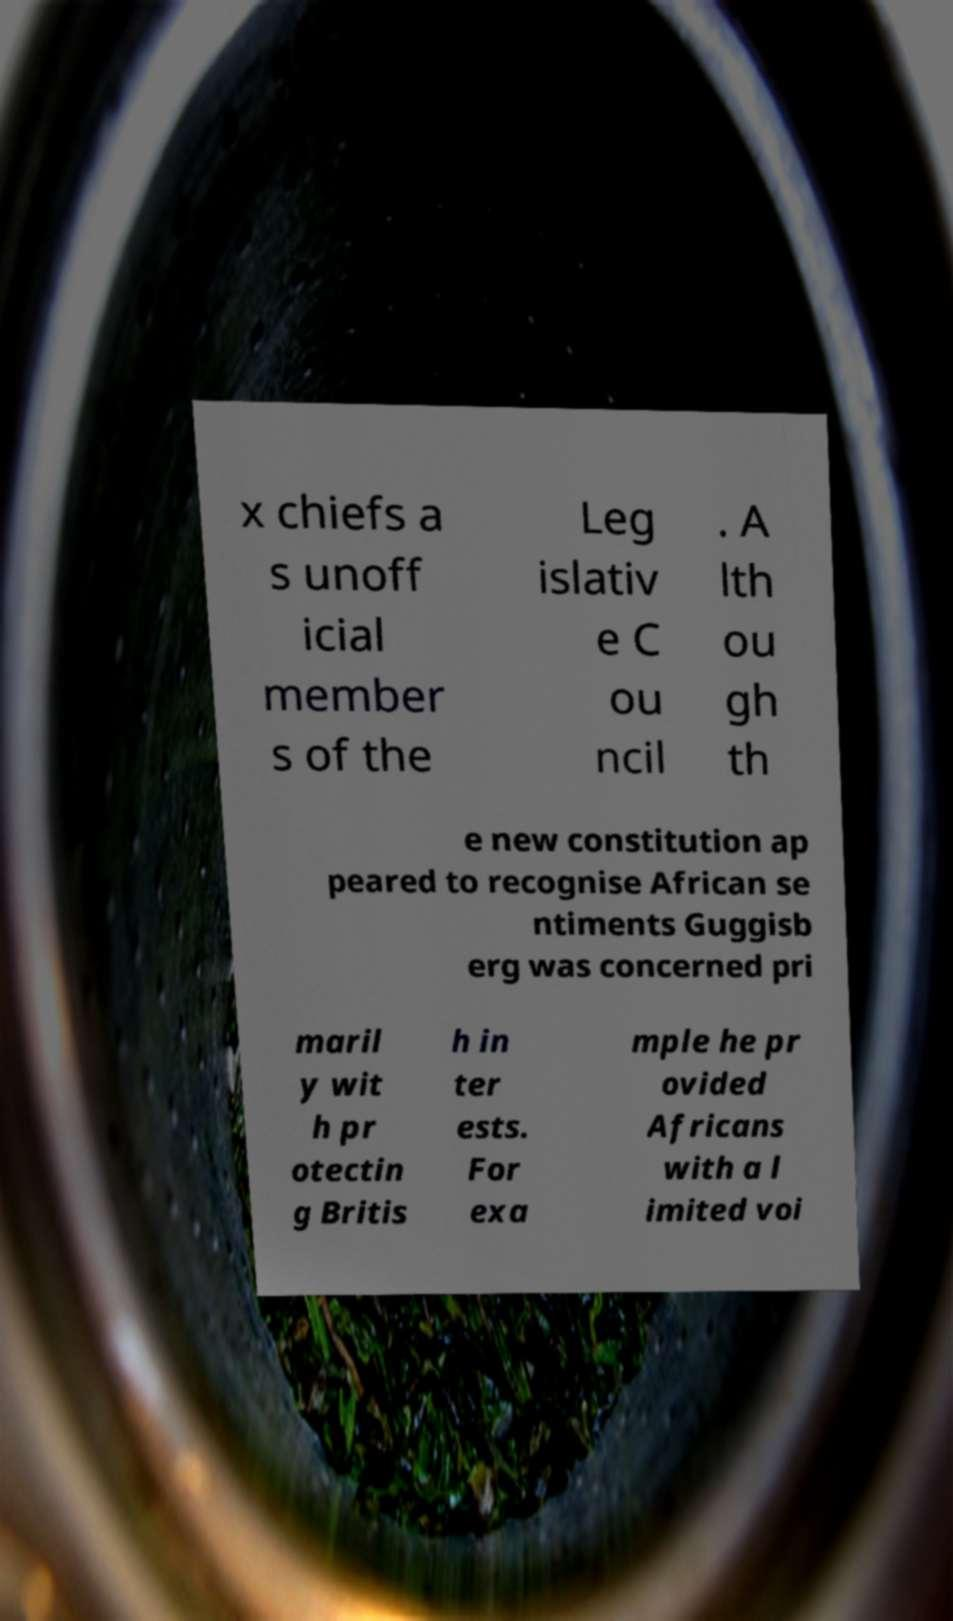Please identify and transcribe the text found in this image. x chiefs a s unoff icial member s of the Leg islativ e C ou ncil . A lth ou gh th e new constitution ap peared to recognise African se ntiments Guggisb erg was concerned pri maril y wit h pr otectin g Britis h in ter ests. For exa mple he pr ovided Africans with a l imited voi 